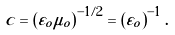<formula> <loc_0><loc_0><loc_500><loc_500>c = \left ( \varepsilon _ { o } \mu _ { o } \right ) ^ { - 1 / 2 } = \left ( \varepsilon _ { o } \right ) ^ { - 1 } .</formula> 